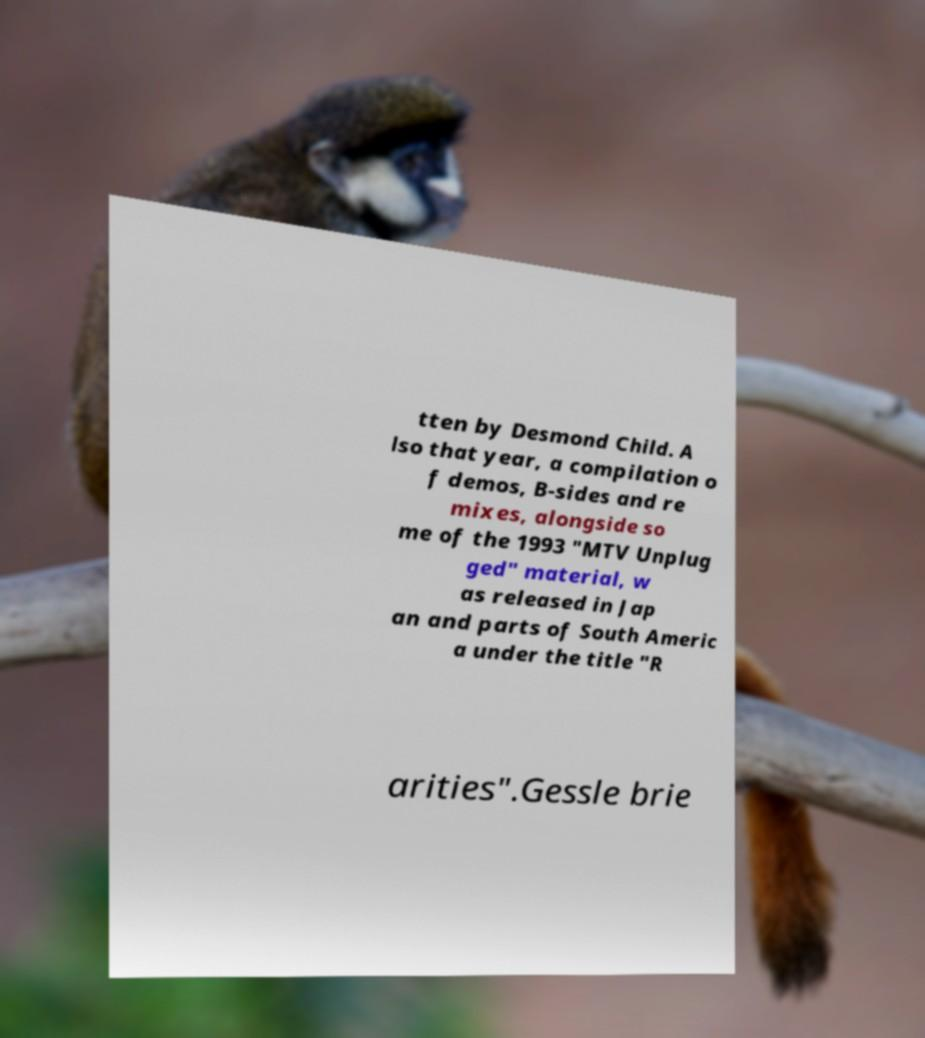What messages or text are displayed in this image? I need them in a readable, typed format. tten by Desmond Child. A lso that year, a compilation o f demos, B-sides and re mixes, alongside so me of the 1993 "MTV Unplug ged" material, w as released in Jap an and parts of South Americ a under the title "R arities".Gessle brie 